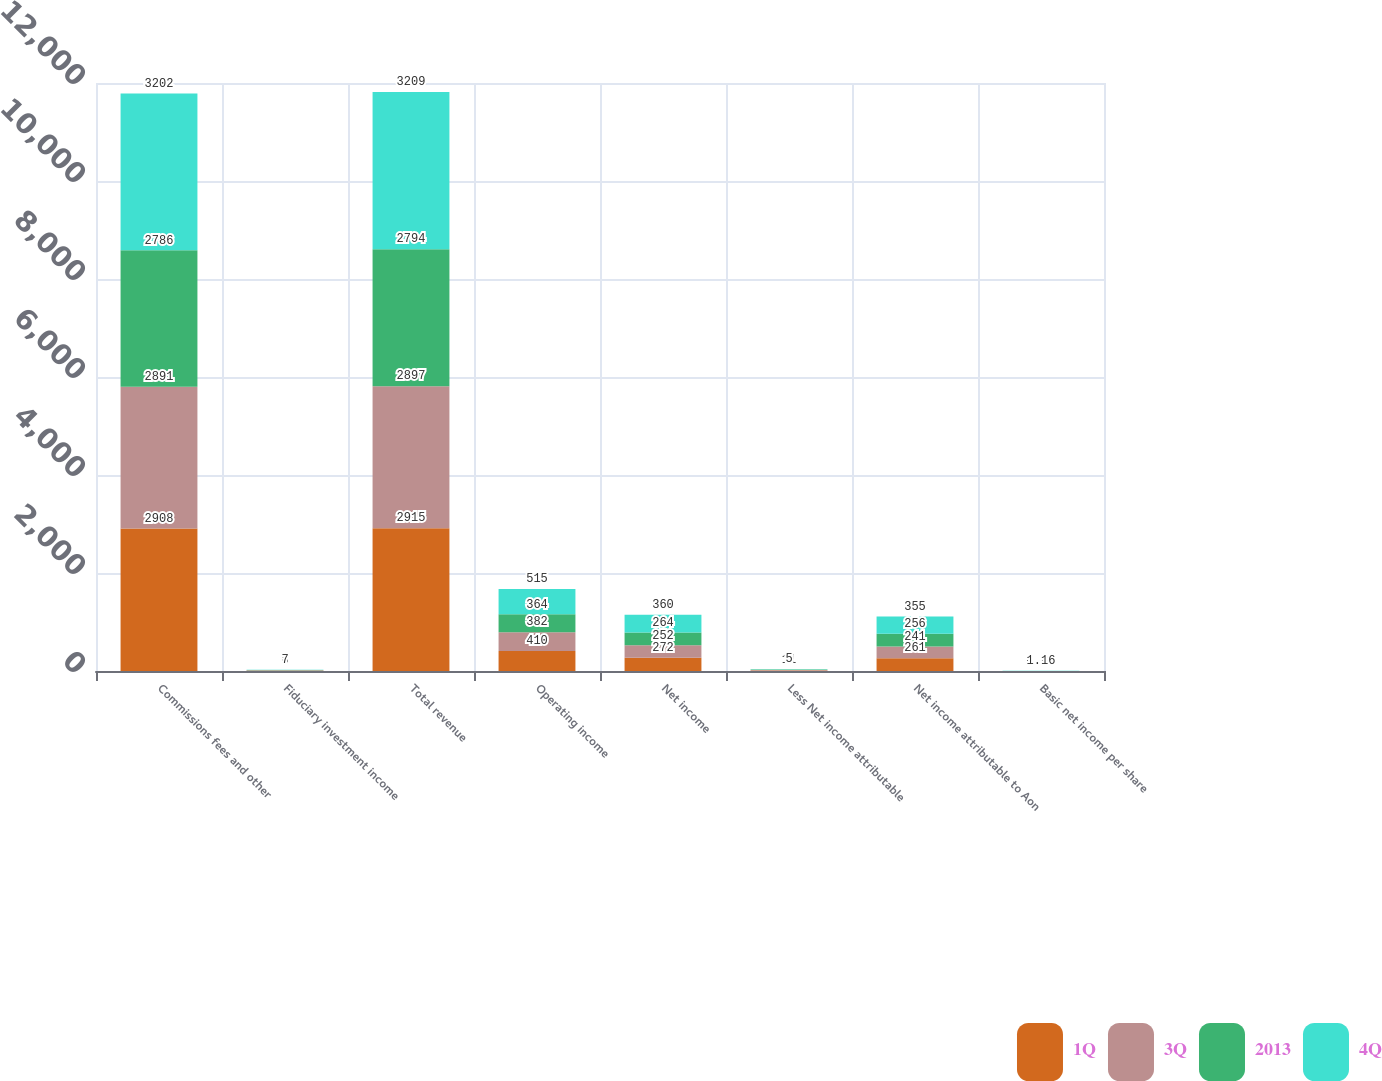<chart> <loc_0><loc_0><loc_500><loc_500><stacked_bar_chart><ecel><fcel>Commissions fees and other<fcel>Fiduciary investment income<fcel>Total revenue<fcel>Operating income<fcel>Net income<fcel>Less Net income attributable<fcel>Net income attributable to Aon<fcel>Basic net income per share<nl><fcel>1Q<fcel>2908<fcel>7<fcel>2915<fcel>410<fcel>272<fcel>11<fcel>261<fcel>0.82<nl><fcel>3Q<fcel>2891<fcel>6<fcel>2897<fcel>382<fcel>252<fcel>11<fcel>241<fcel>0.77<nl><fcel>2013<fcel>2786<fcel>8<fcel>2794<fcel>364<fcel>264<fcel>8<fcel>256<fcel>0.83<nl><fcel>4Q<fcel>3202<fcel>7<fcel>3209<fcel>515<fcel>360<fcel>5<fcel>355<fcel>1.16<nl></chart> 